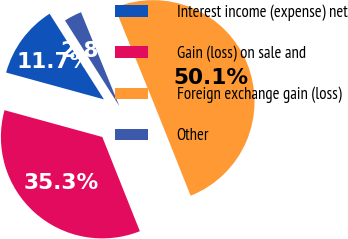<chart> <loc_0><loc_0><loc_500><loc_500><pie_chart><fcel>Interest income (expense) net<fcel>Gain (loss) on sale and<fcel>Foreign exchange gain (loss)<fcel>Other<nl><fcel>11.74%<fcel>35.29%<fcel>50.13%<fcel>2.83%<nl></chart> 